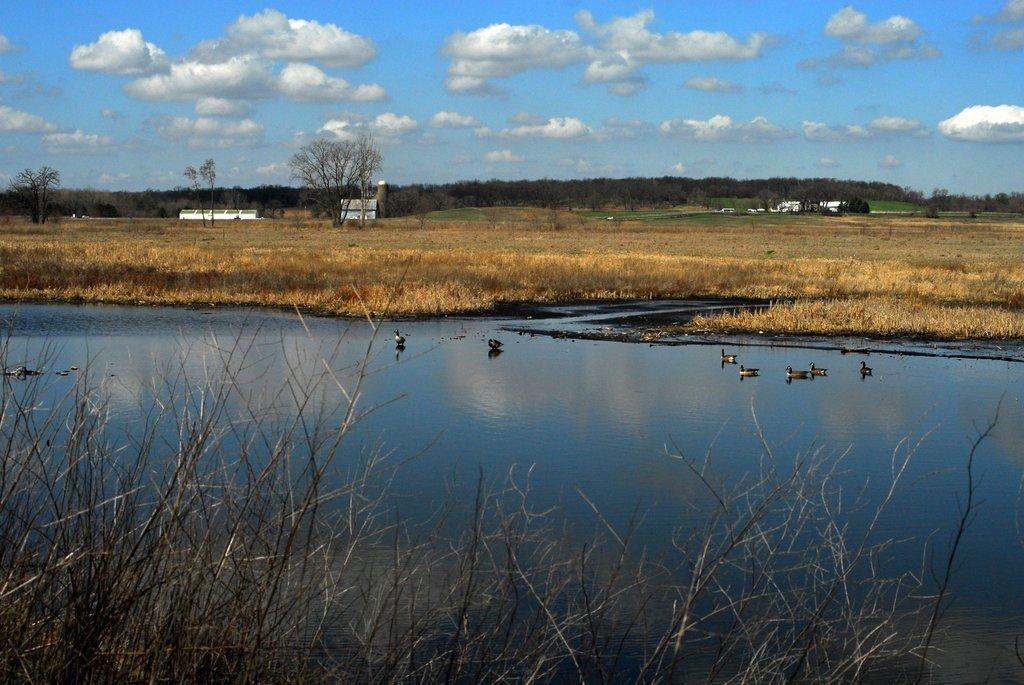Describe this image in one or two sentences. In this picture we can see water in the front, there are some ducks in the water, we can see grass at the bottom, in the background there are some trees and buildings, we can see the sky at the top of the picture. 